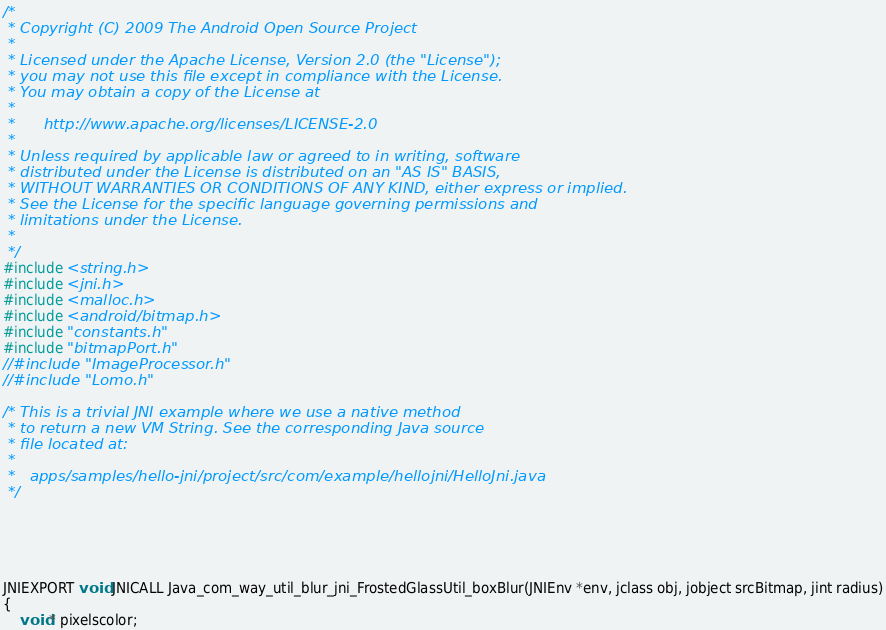<code> <loc_0><loc_0><loc_500><loc_500><_C_>/*
 * Copyright (C) 2009 The Android Open Source Project
 *
 * Licensed under the Apache License, Version 2.0 (the "License");
 * you may not use this file except in compliance with the License.
 * You may obtain a copy of the License at
 *
 *      http://www.apache.org/licenses/LICENSE-2.0
 *
 * Unless required by applicable law or agreed to in writing, software
 * distributed under the License is distributed on an "AS IS" BASIS,
 * WITHOUT WARRANTIES OR CONDITIONS OF ANY KIND, either express or implied.
 * See the License for the specific language governing permissions and
 * limitations under the License.
 *
 */
#include <string.h>
#include <jni.h>
#include <malloc.h>
#include <android/bitmap.h>
#include "constants.h"
#include "bitmapPort.h"
//#include "ImageProcessor.h"
//#include "Lomo.h"

/* This is a trivial JNI example where we use a native method
 * to return a new VM String. See the corresponding Java source
 * file located at:
 *
 *   apps/samples/hello-jni/project/src/com/example/hellojni/HelloJni.java
 */





JNIEXPORT void JNICALL Java_com_way_util_blur_jni_FrostedGlassUtil_boxBlur(JNIEnv *env, jclass obj, jobject srcBitmap, jint radius)
{
  	void* pixelscolor;</code> 